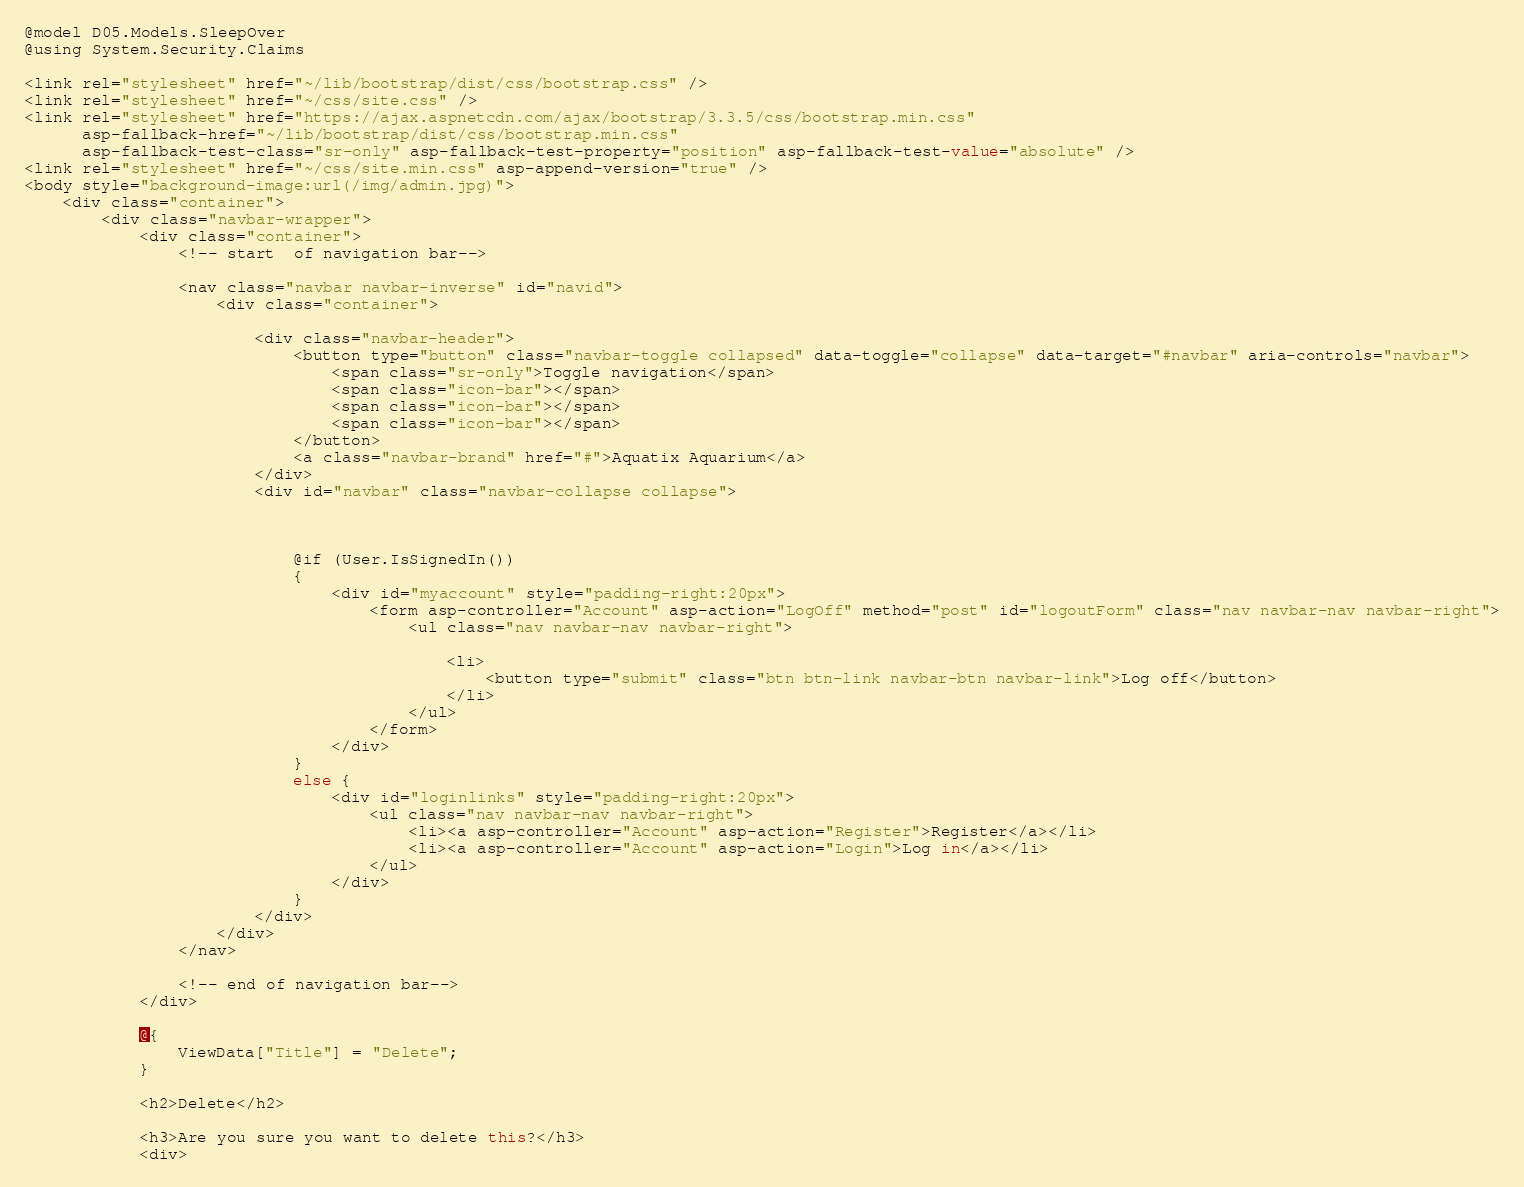Convert code to text. <code><loc_0><loc_0><loc_500><loc_500><_C#_>@model D05.Models.SleepOver
@using System.Security.Claims

<link rel="stylesheet" href="~/lib/bootstrap/dist/css/bootstrap.css" />
<link rel="stylesheet" href="~/css/site.css" />
<link rel="stylesheet" href="https://ajax.aspnetcdn.com/ajax/bootstrap/3.3.5/css/bootstrap.min.css"
      asp-fallback-href="~/lib/bootstrap/dist/css/bootstrap.min.css"
      asp-fallback-test-class="sr-only" asp-fallback-test-property="position" asp-fallback-test-value="absolute" />
<link rel="stylesheet" href="~/css/site.min.css" asp-append-version="true" />
<body style="background-image:url(/img/admin.jpg)">
    <div class="container">
        <div class="navbar-wrapper">
            <div class="container">
                <!-- start  of navigation bar-->

                <nav class="navbar navbar-inverse" id="navid">
                    <div class="container">

                        <div class="navbar-header">
                            <button type="button" class="navbar-toggle collapsed" data-toggle="collapse" data-target="#navbar" aria-controls="navbar">
                                <span class="sr-only">Toggle navigation</span>
                                <span class="icon-bar"></span>
                                <span class="icon-bar"></span>
                                <span class="icon-bar"></span>
                            </button>
                            <a class="navbar-brand" href="#">Aquatix Aquarium</a>
                        </div>
                        <div id="navbar" class="navbar-collapse collapse">



                            @if (User.IsSignedIn())
                            {
                                <div id="myaccount" style="padding-right:20px">
                                    <form asp-controller="Account" asp-action="LogOff" method="post" id="logoutForm" class="nav navbar-nav navbar-right">
                                        <ul class="nav navbar-nav navbar-right">

                                            <li>
                                                <button type="submit" class="btn btn-link navbar-btn navbar-link">Log off</button>
                                            </li>
                                        </ul>
                                    </form>
                                </div>
                            }
                            else {
                                <div id="loginlinks" style="padding-right:20px">
                                    <ul class="nav navbar-nav navbar-right">
                                        <li><a asp-controller="Account" asp-action="Register">Register</a></li>
                                        <li><a asp-controller="Account" asp-action="Login">Log in</a></li>
                                    </ul>
                                </div>
                            }
                        </div>
                    </div>
                </nav>

                <!-- end of navigation bar-->
            </div>

            @{
                ViewData["Title"] = "Delete";
            }

            <h2>Delete</h2>

            <h3>Are you sure you want to delete this?</h3>
            <div></code> 